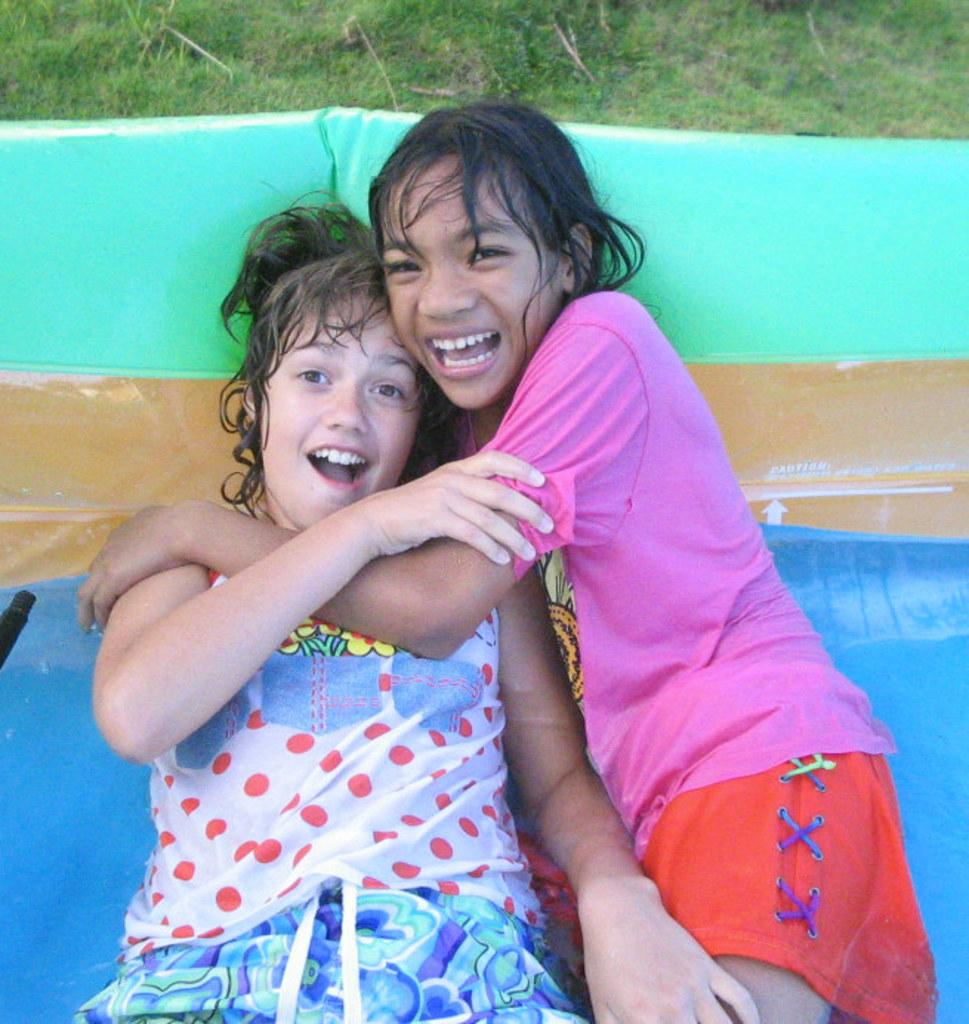What are the two girls doing in the image? The two girls are lying on a water slide in the image. What type of surface is visible at the top of the image? There is grass visible at the top of the image. What type of coat is the girl wearing on the water slide? There is no coat visible in the image, as the girls are wearing swimsuits while lying on the water slide. 